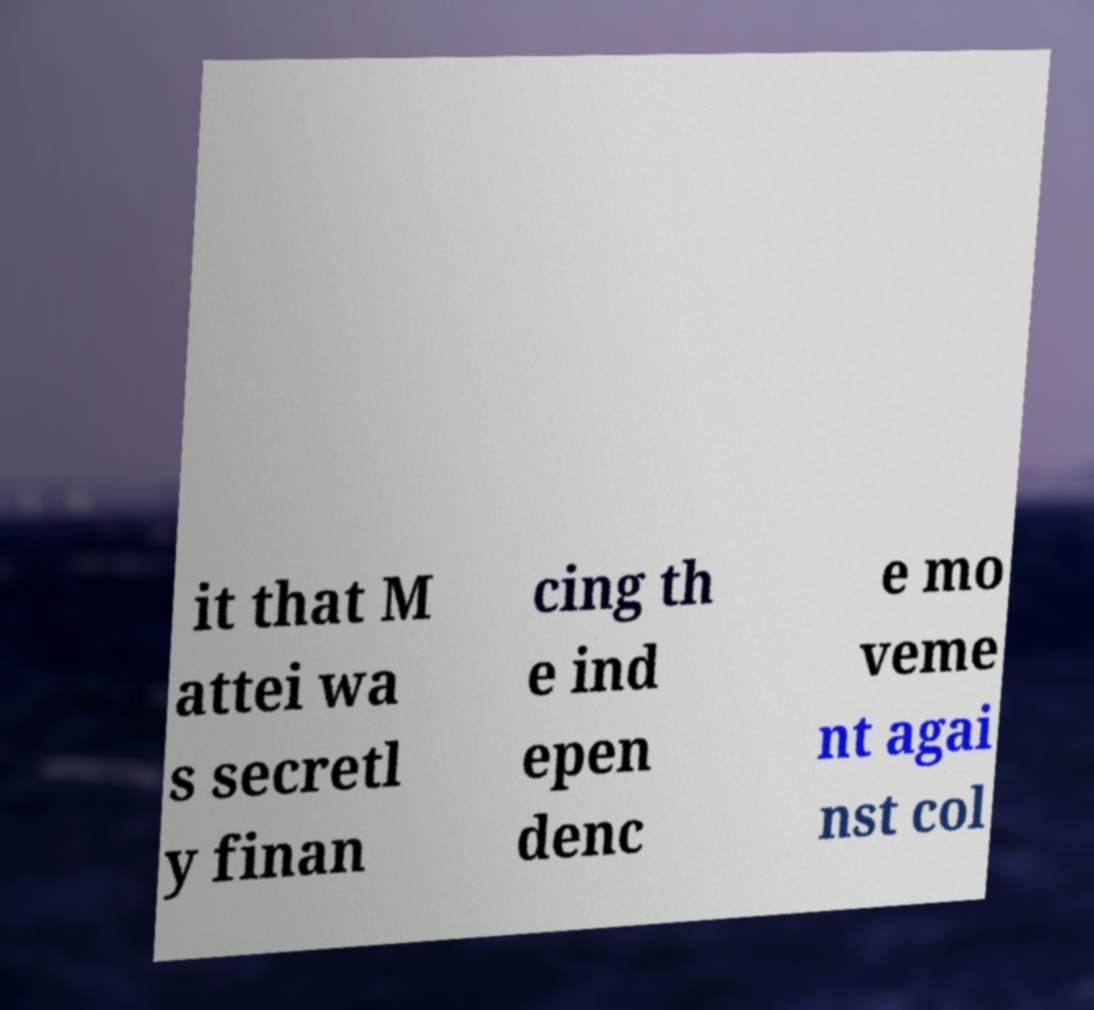What messages or text are displayed in this image? I need them in a readable, typed format. it that M attei wa s secretl y finan cing th e ind epen denc e mo veme nt agai nst col 